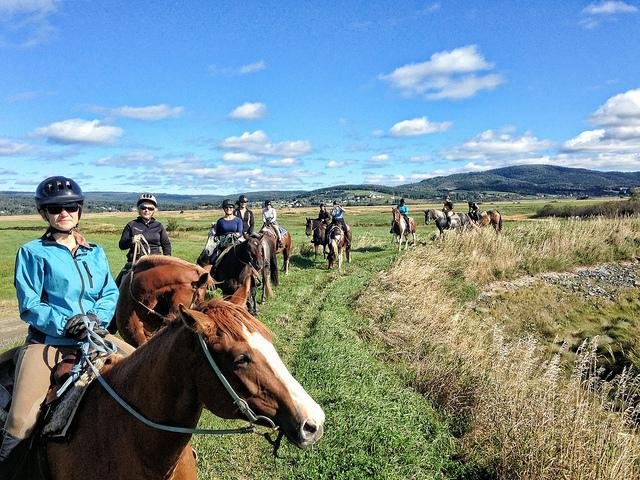What do these horseback riders ride along?

Choices:
A) desert
B) ocean
C) city
D) streambed streambed 